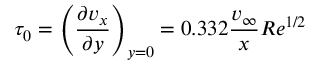Convert formula to latex. <formula><loc_0><loc_0><loc_500><loc_500>\tau _ { 0 } = \left ( { \frac { \partial v _ { x } } { \partial y } } \right ) _ { y = 0 } = 0 . 3 3 2 { \frac { v _ { \infty } } { x } } R e ^ { 1 / 2 }</formula> 